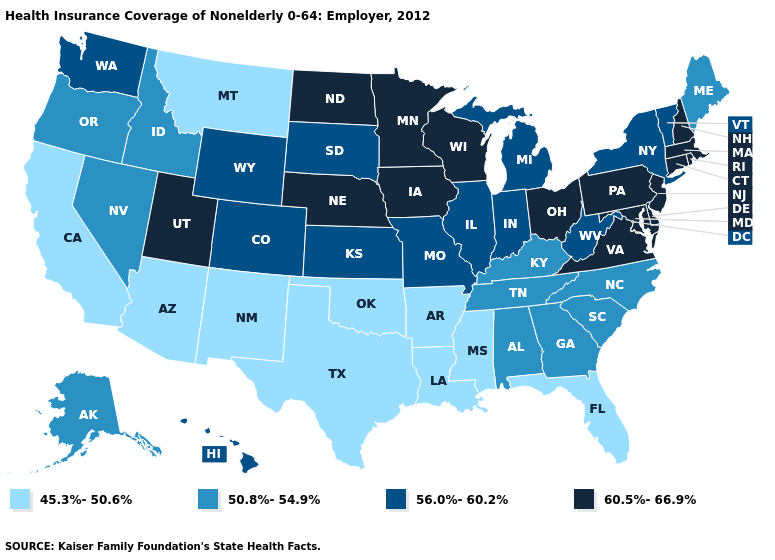Which states have the lowest value in the West?
Answer briefly. Arizona, California, Montana, New Mexico. What is the lowest value in the USA?
Write a very short answer. 45.3%-50.6%. Among the states that border Arizona , does California have the lowest value?
Short answer required. Yes. What is the lowest value in states that border Ohio?
Quick response, please. 50.8%-54.9%. Name the states that have a value in the range 45.3%-50.6%?
Give a very brief answer. Arizona, Arkansas, California, Florida, Louisiana, Mississippi, Montana, New Mexico, Oklahoma, Texas. Does the map have missing data?
Quick response, please. No. Name the states that have a value in the range 60.5%-66.9%?
Write a very short answer. Connecticut, Delaware, Iowa, Maryland, Massachusetts, Minnesota, Nebraska, New Hampshire, New Jersey, North Dakota, Ohio, Pennsylvania, Rhode Island, Utah, Virginia, Wisconsin. What is the value of Pennsylvania?
Answer briefly. 60.5%-66.9%. Name the states that have a value in the range 50.8%-54.9%?
Be succinct. Alabama, Alaska, Georgia, Idaho, Kentucky, Maine, Nevada, North Carolina, Oregon, South Carolina, Tennessee. Does Virginia have the highest value in the South?
Write a very short answer. Yes. Name the states that have a value in the range 60.5%-66.9%?
Quick response, please. Connecticut, Delaware, Iowa, Maryland, Massachusetts, Minnesota, Nebraska, New Hampshire, New Jersey, North Dakota, Ohio, Pennsylvania, Rhode Island, Utah, Virginia, Wisconsin. Which states hav the highest value in the West?
Short answer required. Utah. What is the value of Arizona?
Write a very short answer. 45.3%-50.6%. What is the value of Alabama?
Concise answer only. 50.8%-54.9%. What is the lowest value in the West?
Be succinct. 45.3%-50.6%. 